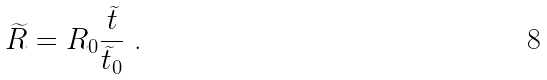Convert formula to latex. <formula><loc_0><loc_0><loc_500><loc_500>\widetilde { R } = R _ { 0 } \frac { \widetilde { t } } { \widetilde { t } _ { 0 } } \text { .}</formula> 